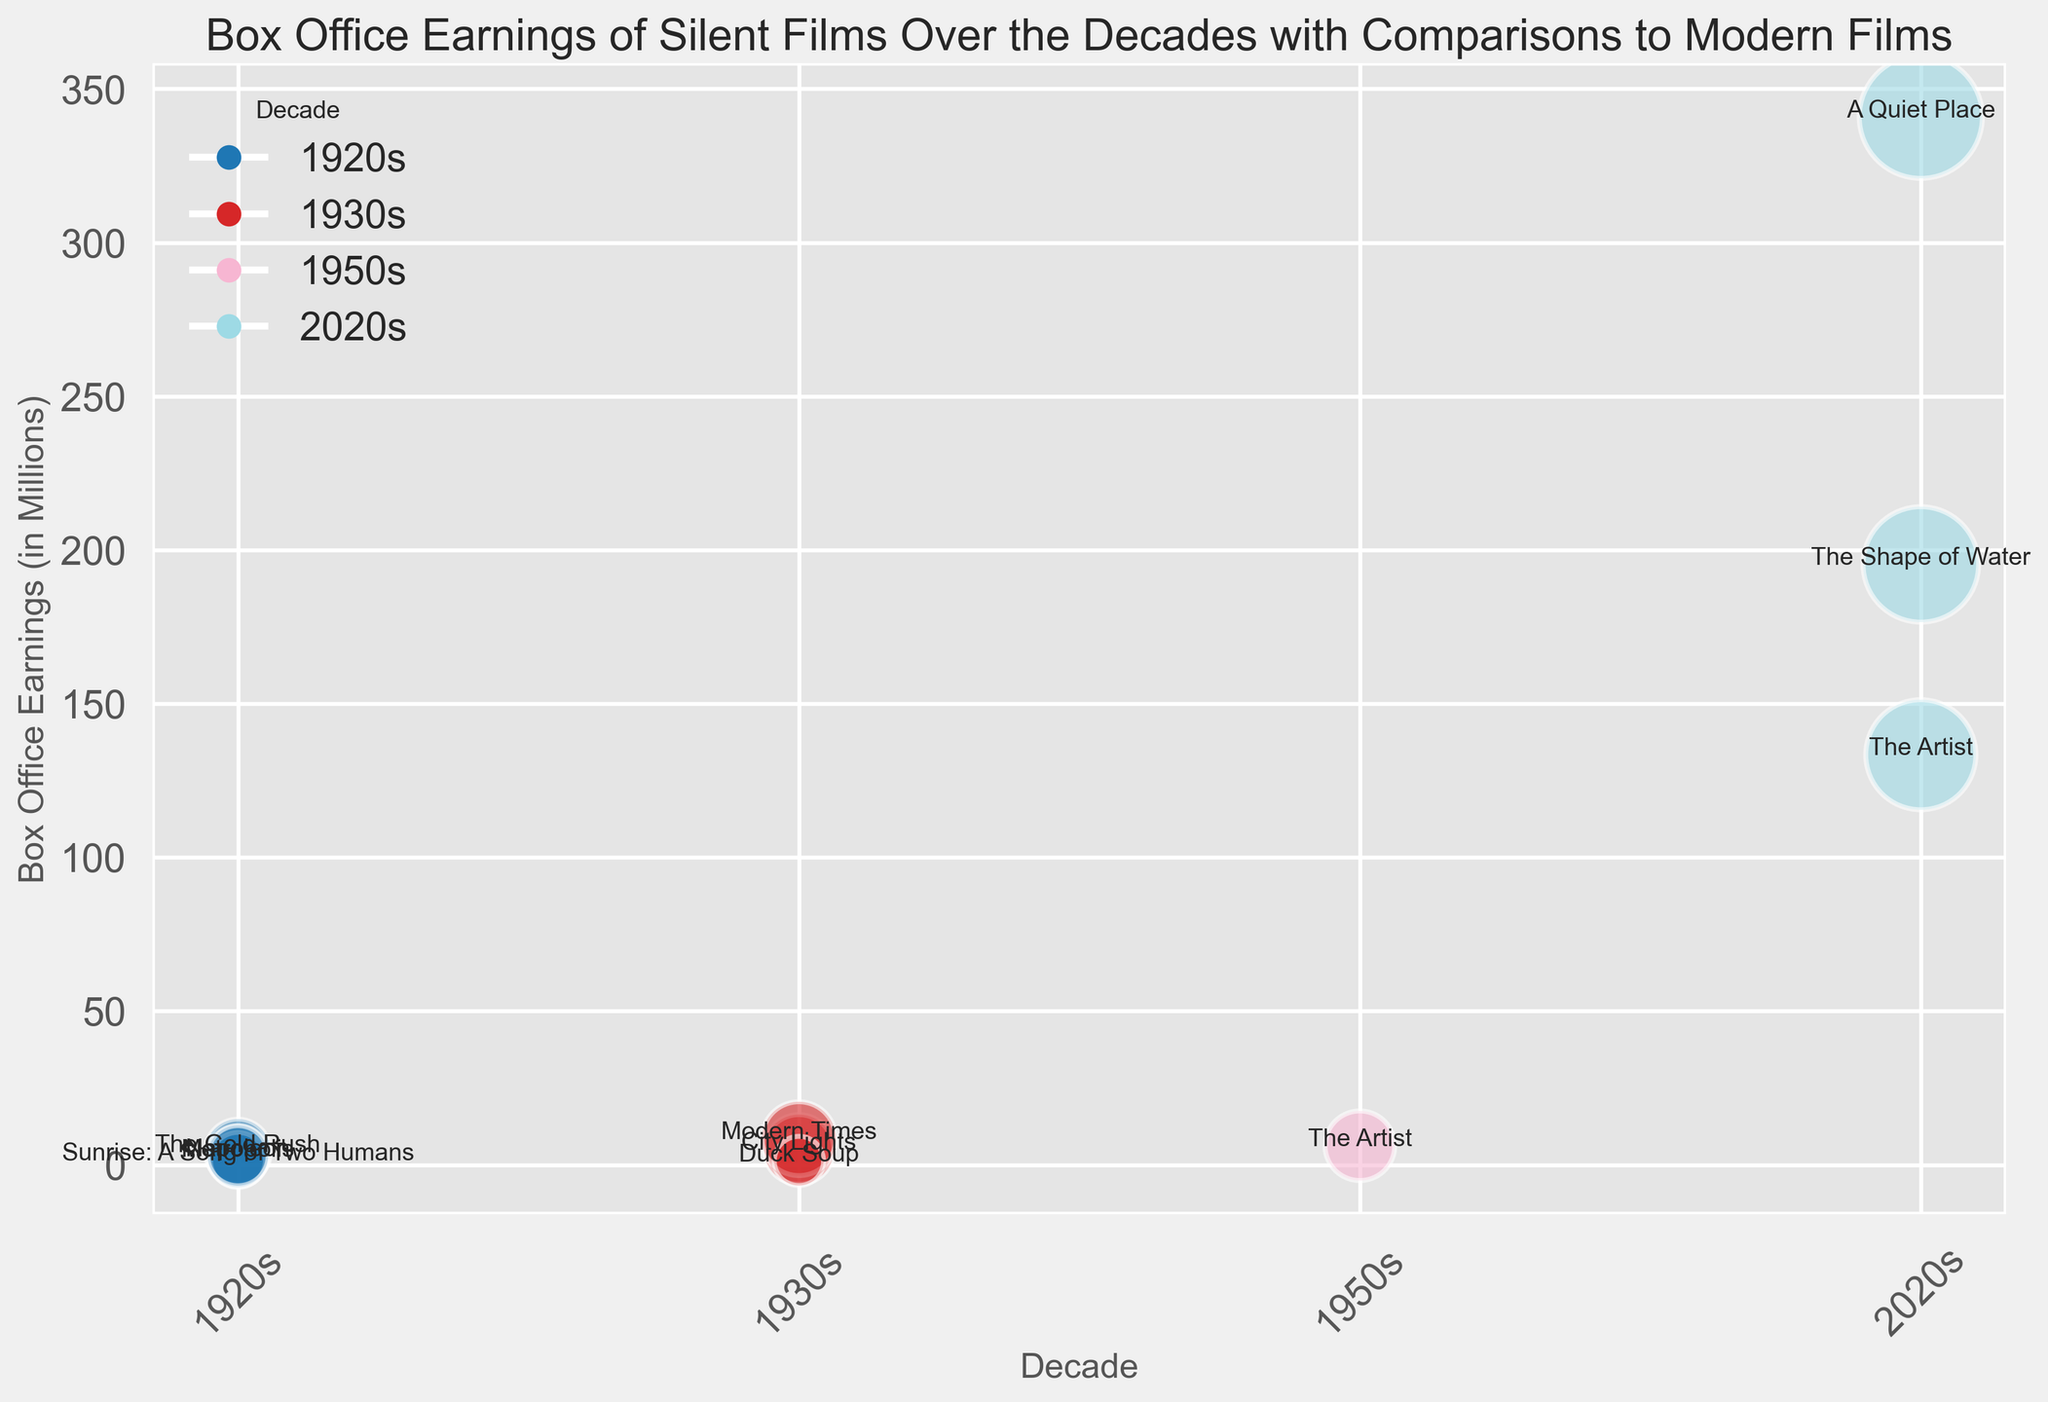Which film has the highest box office earnings in the 1930s? Identify and compare the earnings of films from the 1930s by looking at the height of the bubbles. "Modern Times" has the highest earnings.
Answer: Modern Times Which decade has the highest overall box office earnings? Compare the height of all bubbles grouped by decade. The 2020s have the highest bubbles.
Answer: 2020s How do the box office earnings of "The Artist" in the 1950s compare to its earnings in the 2020s? Compare the height of the bubbles labeled "The Artist" across the two decades. The earnings in the 2020s are higher than in the 1950s.
Answer: Higher in the 2020s Which film from the 1920s has the largest bubble size? Compare the sizes of the bubbles from the 1920s by observing their area. "The Gold Rush" has the largest bubble size.
Answer: The Gold Rush Which decade has the most consistent box office earnings across its films? Observe the distribution and range of bubble heights within each decade. The 1930s have more evenly distributed bubble heights compared to other decades.
Answer: 1930s What is the total box office earnings for films from the 2020s shown in the figure? Sum the box office earnings of "A Quiet Place," "The Artist," and "The Shape of Water." 340.9 + 133.4 + 195.3 = 669.6
Answer: 669.6 Which film from the 1920s has the lowest box office earnings? Identify and compare the heights of the bubbles from the 1920s. "Sunrise: A Song of Two Humans" has the lowest earnings.
Answer: Sunrise: A Song of Two Humans Compare the overall trends in box office earnings between silent films of the 1920s and modern films of the 2020s. Visually observe the overall heights of bubbles and note that modern films generally have higher earnings compared to silent films of the 1920s.
Answer: Modern films have higher earnings What is the average box office earnings of films from the 1930s shown in the figure? Add the box office earnings of films from the 1930s and divide by the number of those films. (5.0 + 8.5 + 1.25) / 3 = 4.92
Answer: 4.92 